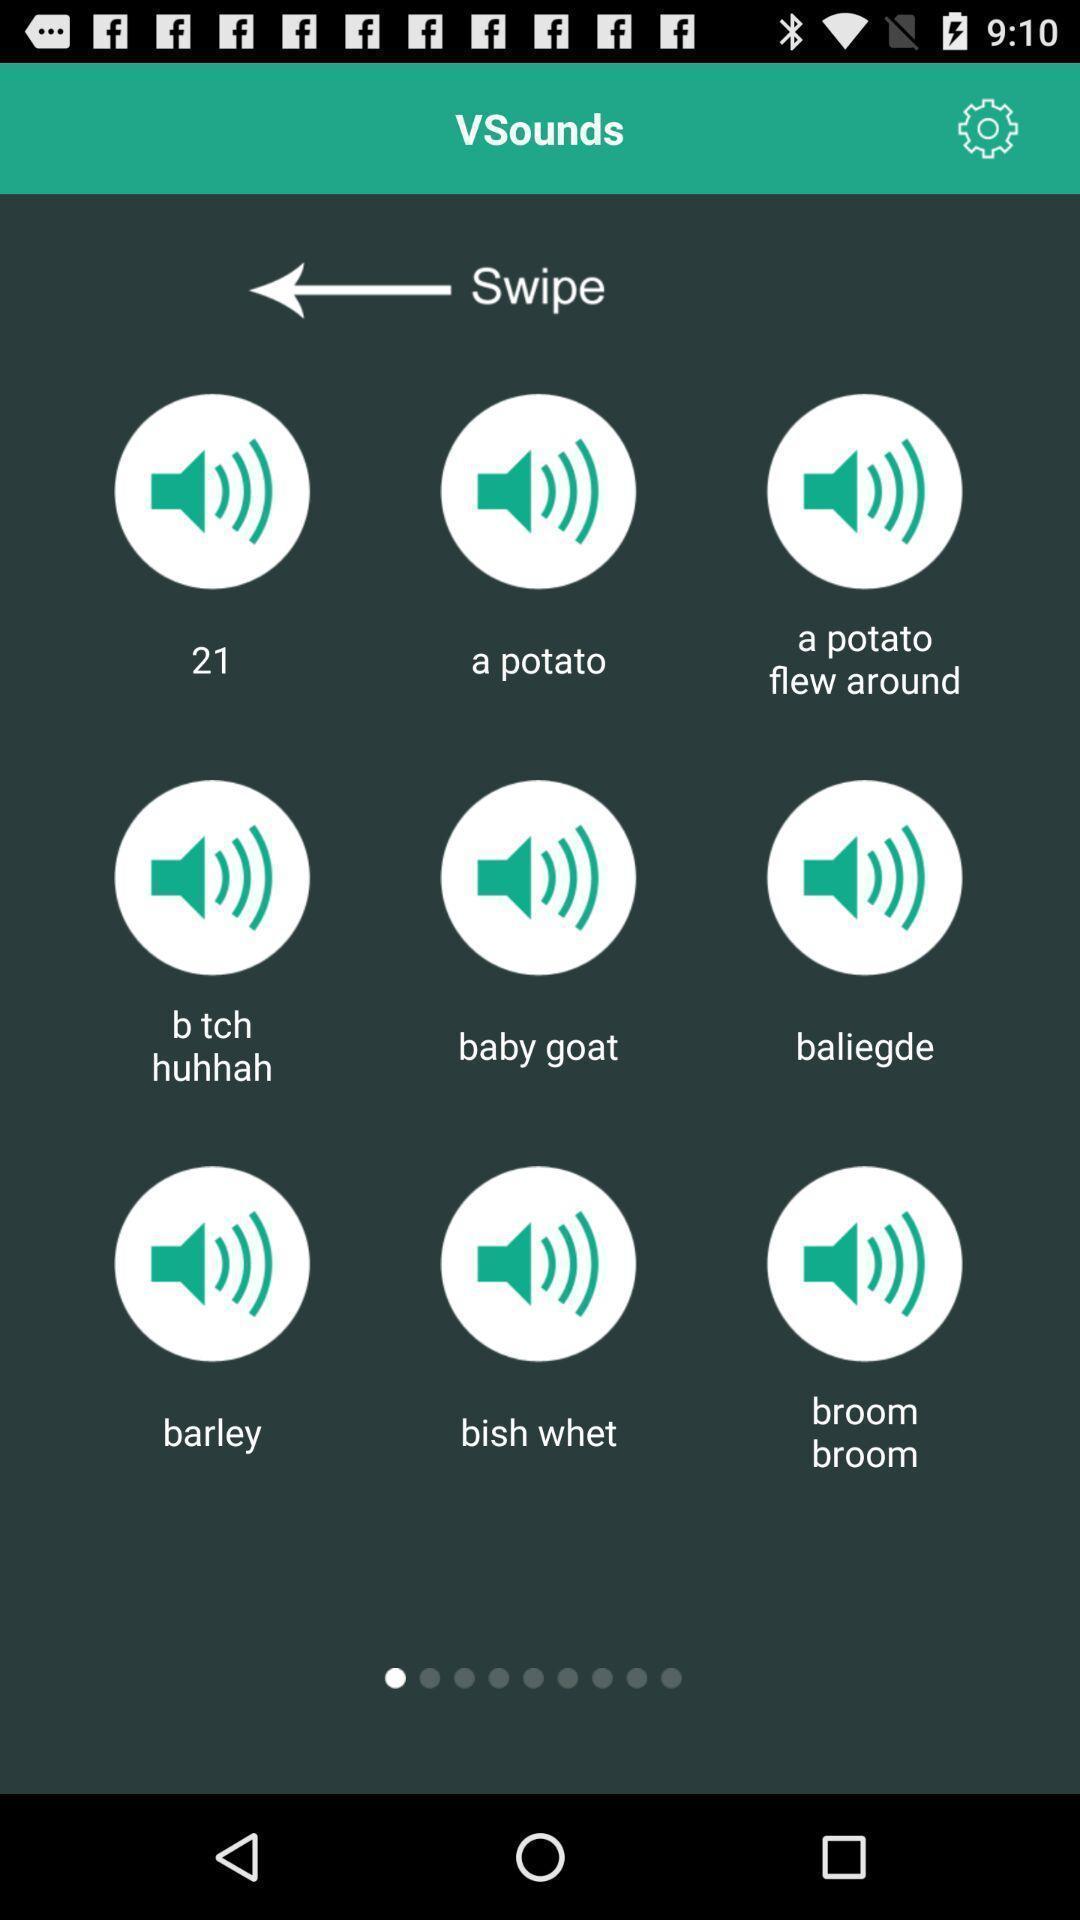What details can you identify in this image? Page showing different icons with swipe option. 